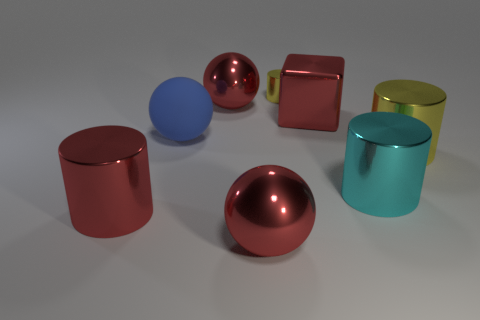Add 1 blue rubber spheres. How many objects exist? 9 Subtract all cubes. How many objects are left? 7 Add 8 yellow metal balls. How many yellow metal balls exist? 8 Subtract 0 gray cubes. How many objects are left? 8 Subtract all small cyan shiny blocks. Subtract all metallic cylinders. How many objects are left? 4 Add 5 cyan things. How many cyan things are left? 6 